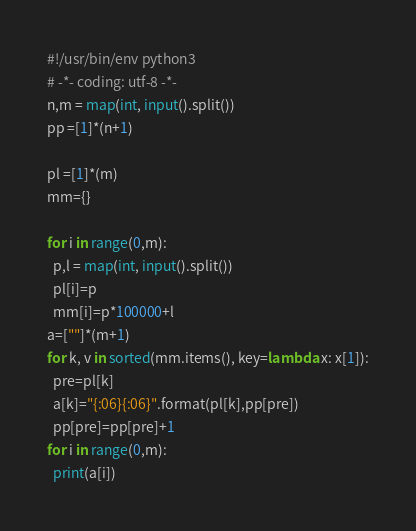<code> <loc_0><loc_0><loc_500><loc_500><_Python_>#!/usr/bin/env python3
# -*- coding: utf-8 -*-
n,m = map(int, input().split())
pp =[1]*(n+1)

pl =[1]*(m)
mm={}

for i in range(0,m):
  p,l = map(int, input().split())
  pl[i]=p
  mm[i]=p*100000+l
a=[""]*(m+1)
for k, v in sorted(mm.items(), key=lambda x: x[1]):
  pre=pl[k]
  a[k]="{:06}{:06}".format(pl[k],pp[pre])
  pp[pre]=pp[pre]+1
for i in range(0,m):
  print(a[i])
</code> 